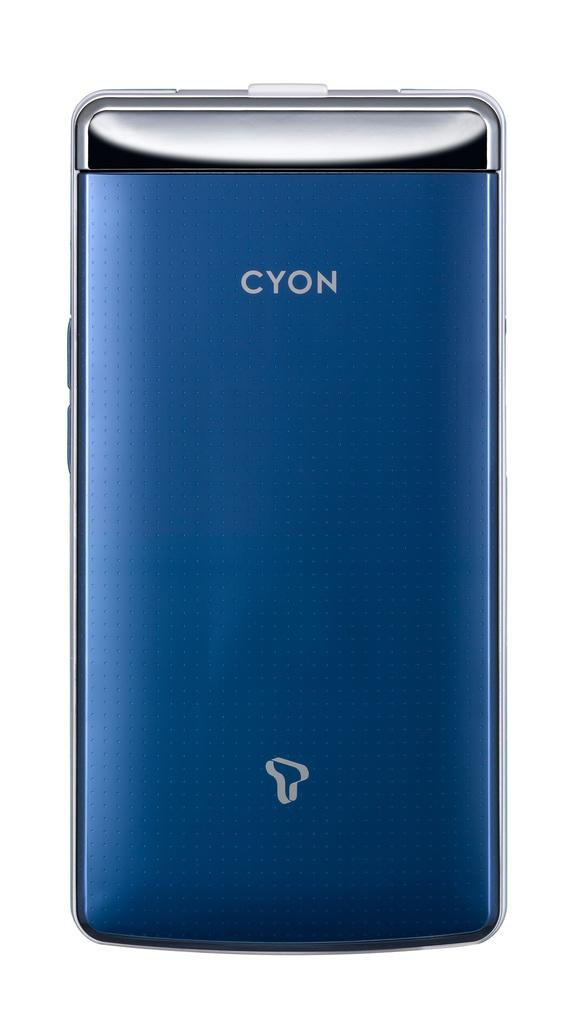<image>
Describe the image concisely. A blue cyon phone against a white backdrop. 